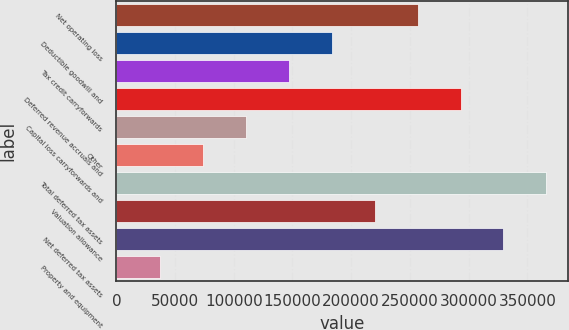Convert chart to OTSL. <chart><loc_0><loc_0><loc_500><loc_500><bar_chart><fcel>Net operating loss<fcel>Deductible goodwill and<fcel>Tax credit carryforwards<fcel>Deferred revenue accruals and<fcel>Capital loss carryforwards and<fcel>Other<fcel>Total deferred tax assets<fcel>Valuation allowance<fcel>Net deferred tax assets<fcel>Property and equipment<nl><fcel>256485<fcel>183310<fcel>146722<fcel>293073<fcel>110135<fcel>73547.2<fcel>366248<fcel>219898<fcel>329660<fcel>36959.6<nl></chart> 